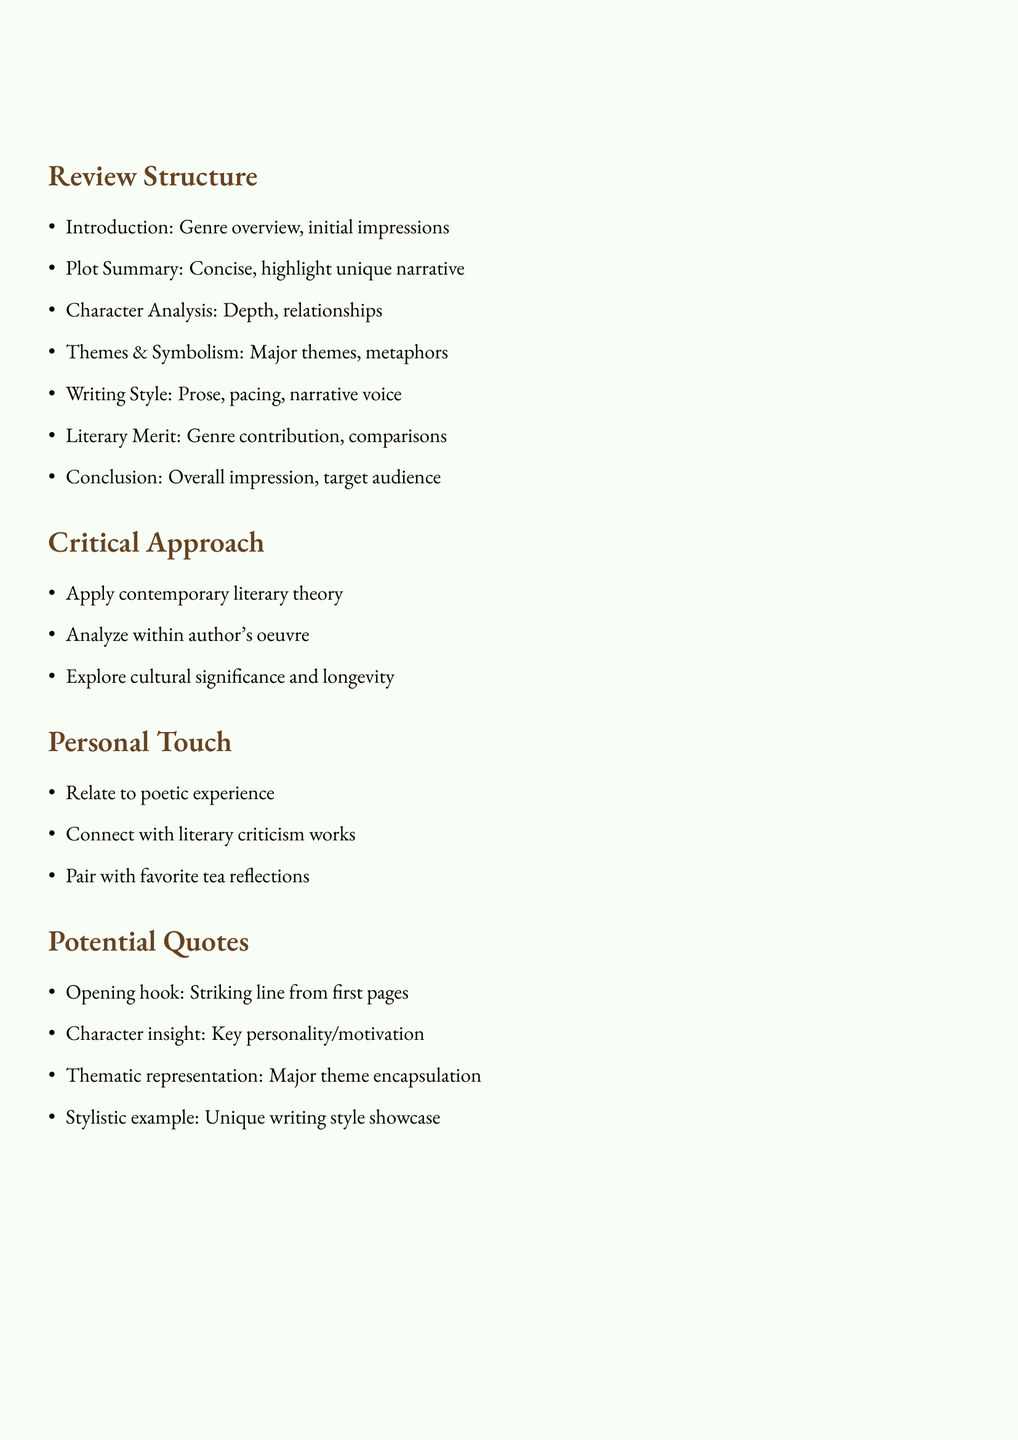What are the sections outlined for the book review? The sections include Introduction, Plot Summary, Character Analysis, Themes and Symbolism, Writing Style, Literary Merit, and Conclusion.
Answer: Introduction, Plot Summary, Character Analysis, Themes and Symbolism, Writing Style, Literary Merit, Conclusion What is included in the Character Analysis section? The points discussed in the Character Analysis section are depth and development of main characters, and character relationships and their impact on the story.
Answer: Depth and development of main characters, character relationships and their impact on the story What objectives are associated with the Critical Approach? The document outlines three objectives under the Critical Approach: applying contemporary literary theory, analyzing within the author's oeuvre, and exploring cultural significance.
Answer: Apply contemporary literary theory, analyze within author's oeuvre, explore cultural significance How many points are listed under the Writing Style section? The Writing Style section has two points: evaluating the author's prose and use of language, and commenting on pacing and narrative voice.
Answer: Two points What quote purpose is mentioned for revealing character insight? The potential quote purpose for revealing character insight focuses on choosing a quote that reveals a key character's personality or motivation.
Answer: Key character's personality or motivation Which section of the review summarizes the overall impression? The Conclusion section summarizes the overall impression.
Answer: Conclusion 